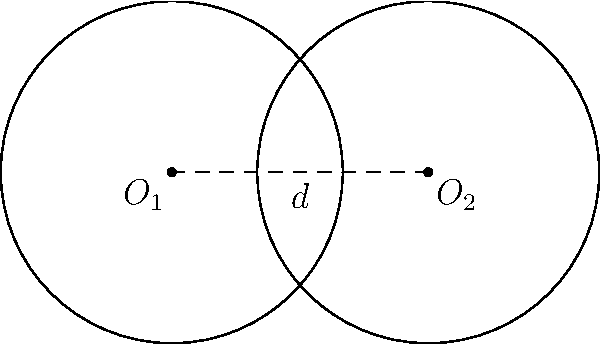Given two circles with centers $O_1$ and $O_2$ and equal radii of 2 units, separated by a distance of 3 units, calculate the area of their overlap region. Use LINQ method syntax to implement a function that computes this area for any given radius and distance between centers. To solve this problem, we'll follow these steps:

1. Identify the formula for the area of overlap between two circles:
   $$A = 2r^2 \arccos(\frac{d}{2r}) - d\sqrt{r^2 - \frac{d^2}{4}}$$
   where $r$ is the radius of both circles and $d$ is the distance between their centers.

2. Implement a C# function using LINQ method syntax to calculate the area:

```csharp
public static double CalculateOverlapArea(double radius, double distance)
{
    return Enumerable.Range(0, 1)
        .Select(_ => 2 * Math.Pow(radius, 2) * Math.Acos(distance / (2 * radius)))
        .Select(area => area - distance * Math.Sqrt(Math.Pow(radius, 2) - Math.Pow(distance, 2) / 4))
        .First();
}
```

3. For our specific case:
   $r = 2$ and $d = 3$

4. Plug these values into our function:
   ```csharp
   double result = CalculateOverlapArea(2, 3);
   ```

5. The function will perform the calculation:
   $$A = 2(2^2) \arccos(\frac{3}{2(2)}) - 3\sqrt{2^2 - \frac{3^2}{4}}$$
   $$A = 8 \arccos(\frac{3}{4}) - 3\sqrt{4 - \frac{9}{4}}$$
   $$A = 8 \arccos(0.75) - 3\sqrt{1.75}$$

6. Evaluate the result:
   $$A \approx 1.2318 \text{ square units}$$
Answer: 1.2318 square units 